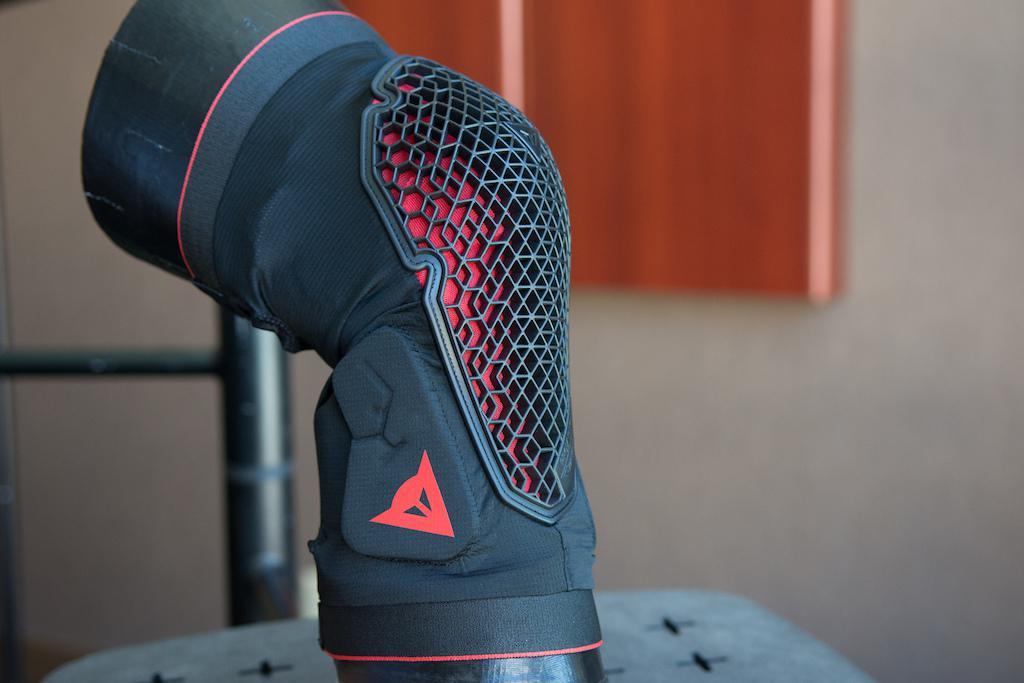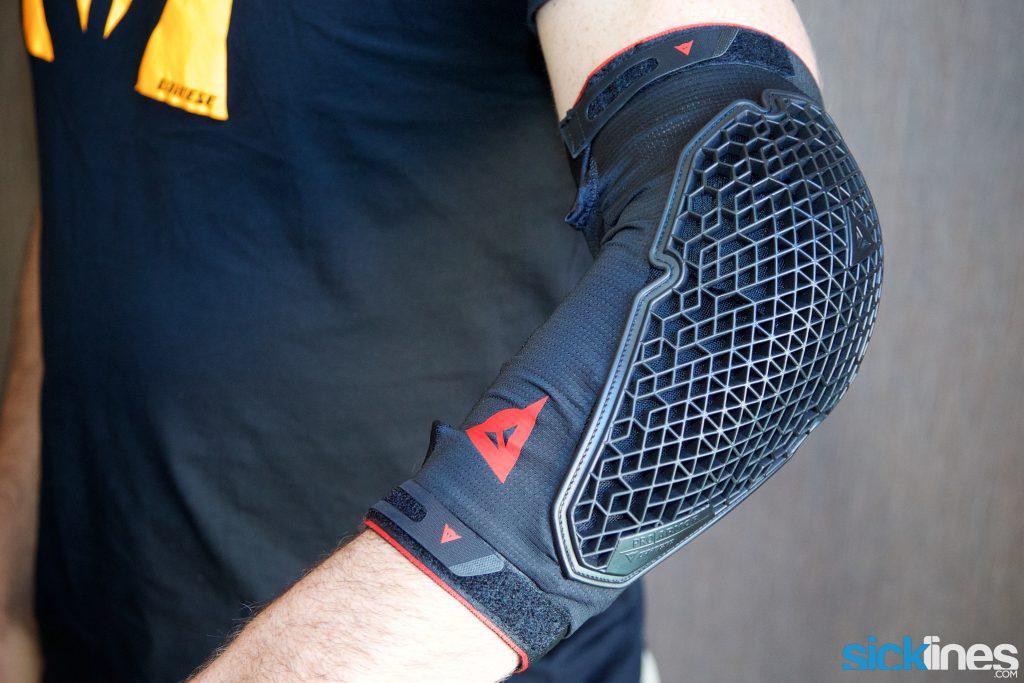The first image is the image on the left, the second image is the image on the right. Assess this claim about the two images: "An image shows a front view of a pair of legs wearing mesh-like kneepads.". Correct or not? Answer yes or no. No. The first image is the image on the left, the second image is the image on the right. Evaluate the accuracy of this statement regarding the images: "Both images show kneepads modelled on human legs.". Is it true? Answer yes or no. No. 